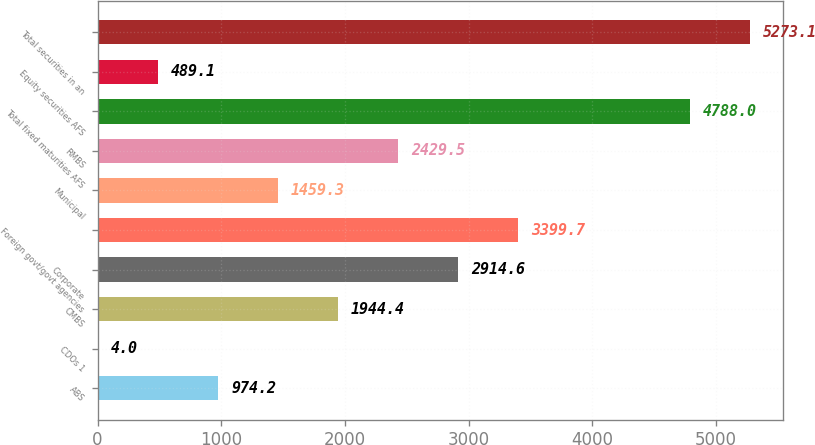Convert chart to OTSL. <chart><loc_0><loc_0><loc_500><loc_500><bar_chart><fcel>ABS<fcel>CDOs 1<fcel>CMBS<fcel>Corporate<fcel>Foreign govt/govt agencies<fcel>Municipal<fcel>RMBS<fcel>Total fixed maturities AFS<fcel>Equity securities AFS<fcel>Total securities in an<nl><fcel>974.2<fcel>4<fcel>1944.4<fcel>2914.6<fcel>3399.7<fcel>1459.3<fcel>2429.5<fcel>4788<fcel>489.1<fcel>5273.1<nl></chart> 